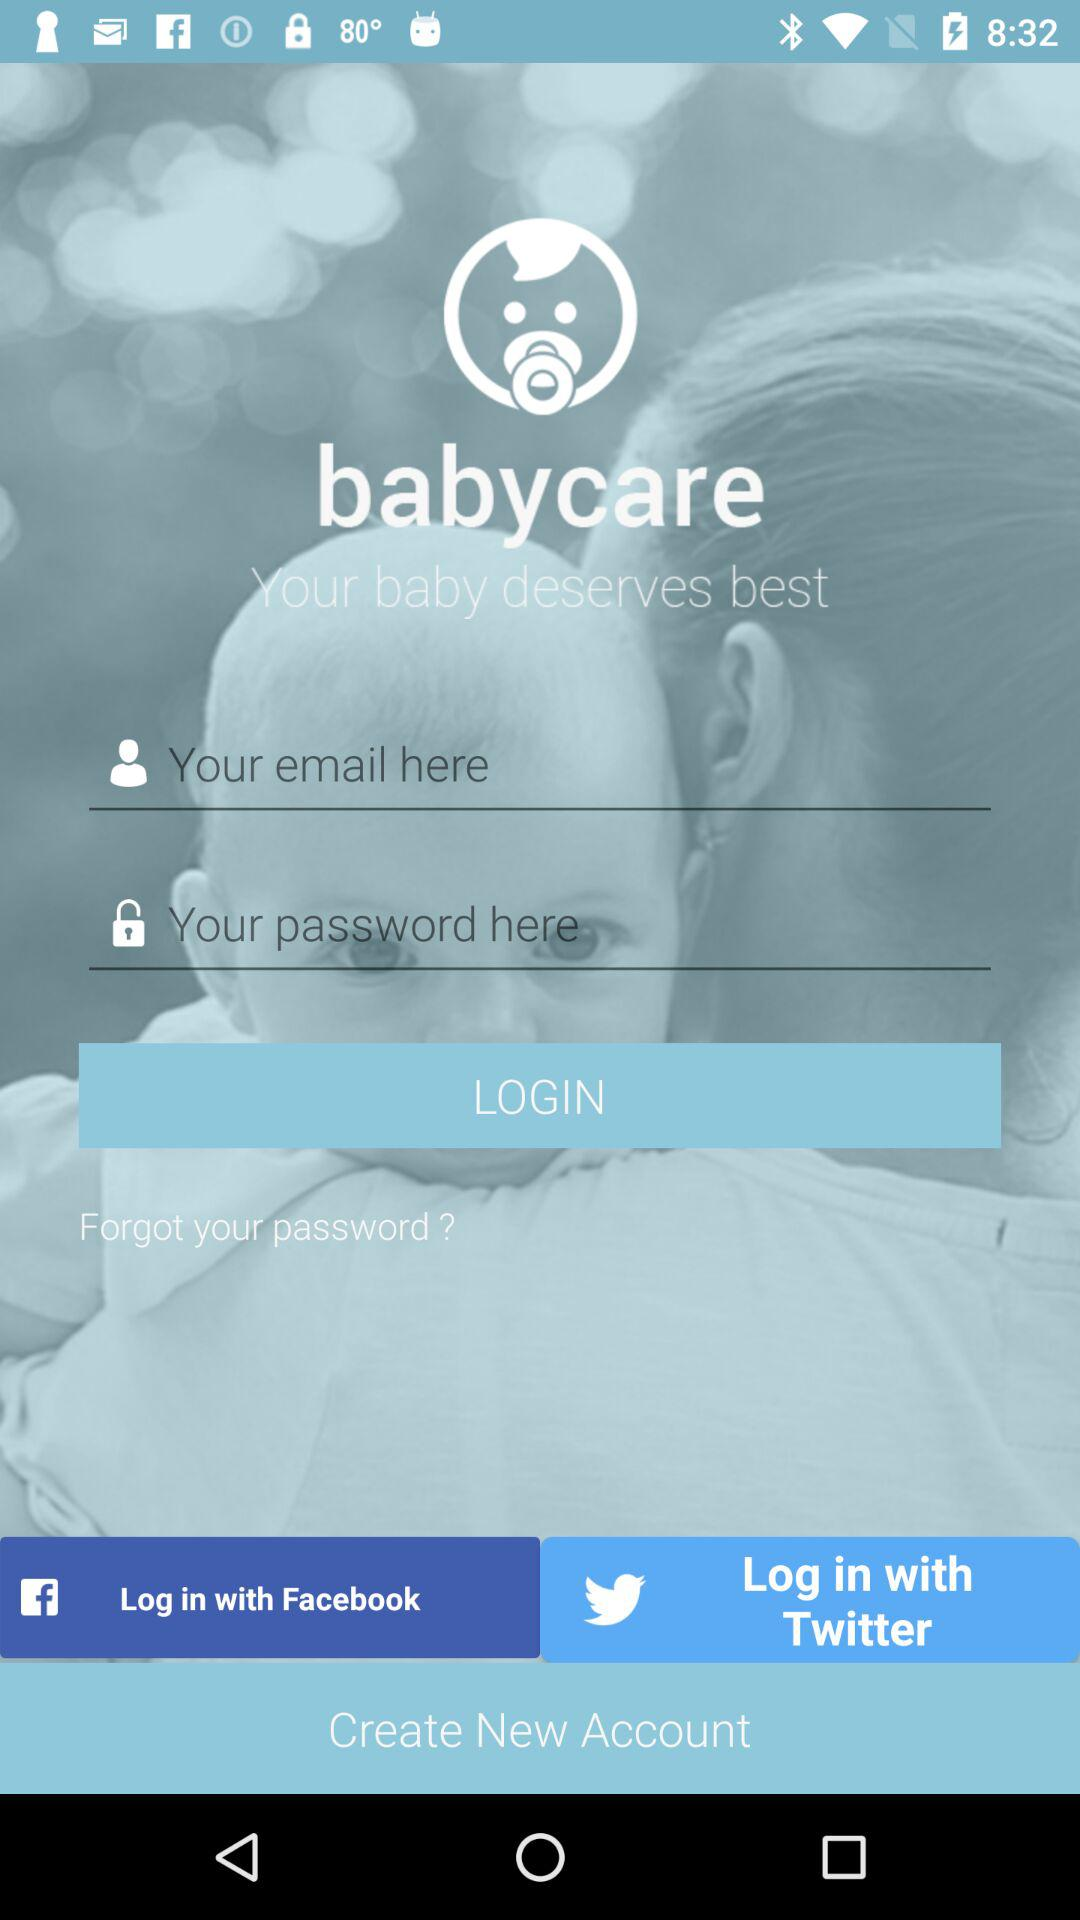Through what application can we log in? You can log in with "email", "Facebook" and "Twitter". 